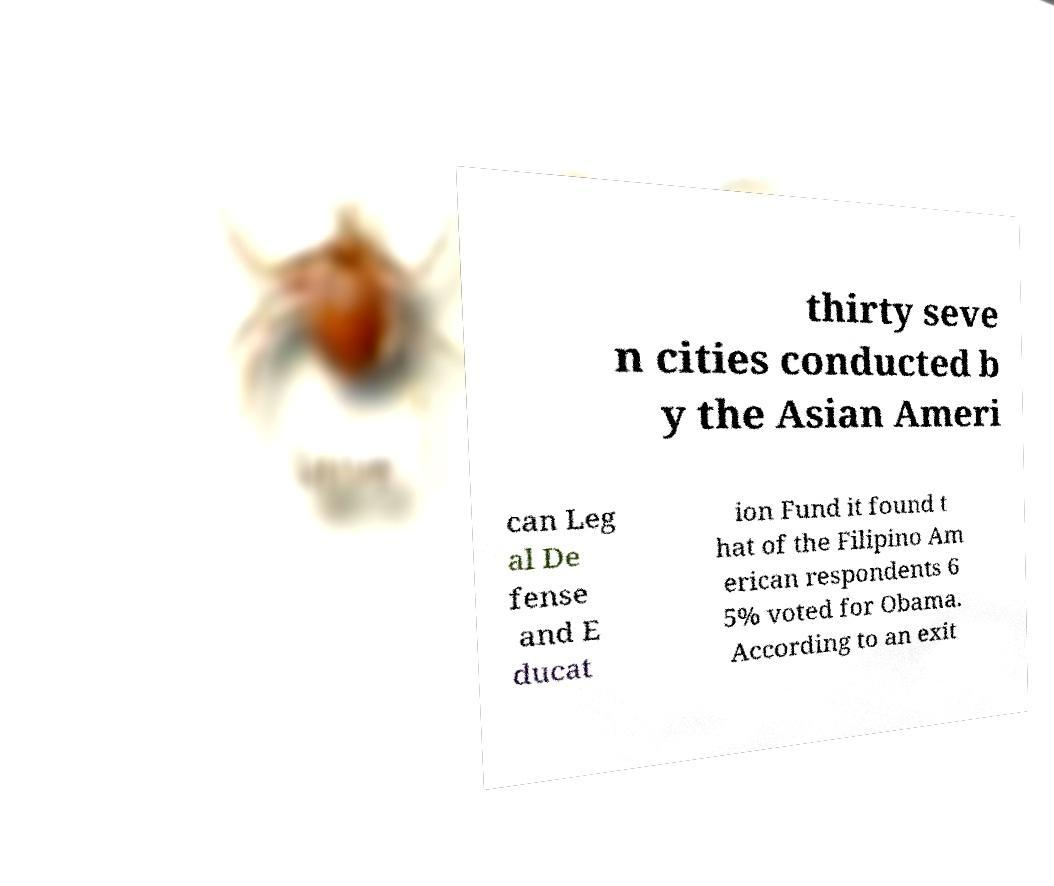There's text embedded in this image that I need extracted. Can you transcribe it verbatim? thirty seve n cities conducted b y the Asian Ameri can Leg al De fense and E ducat ion Fund it found t hat of the Filipino Am erican respondents 6 5% voted for Obama. According to an exit 